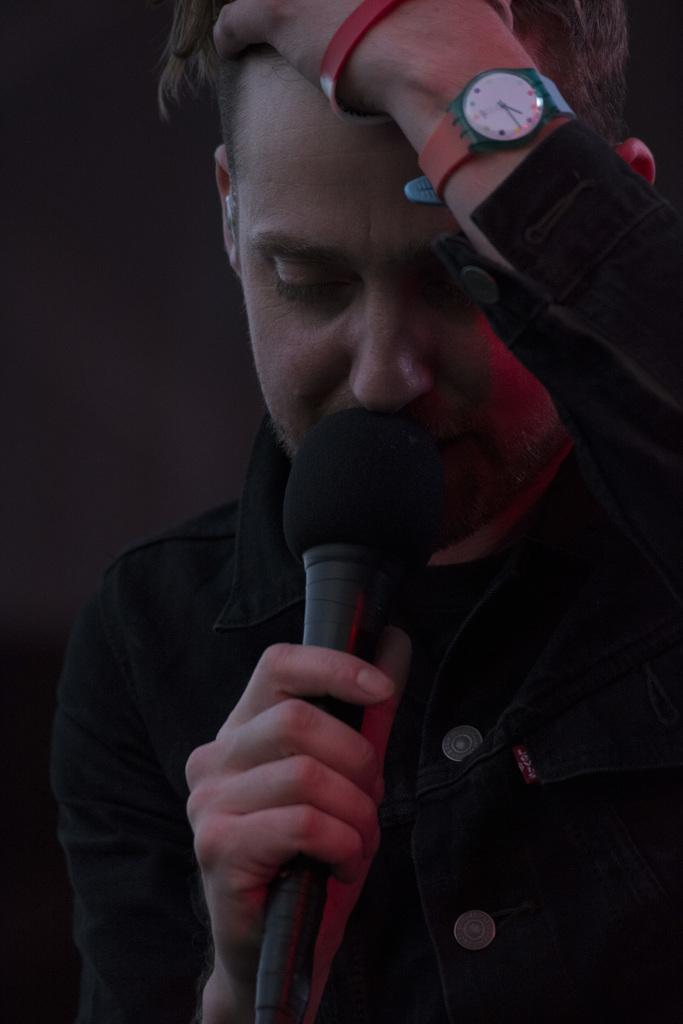Please provide a concise description of this image. In this image i can see a man is holding a mic and wearing a watch in his hands. 